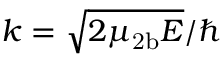<formula> <loc_0><loc_0><loc_500><loc_500>k = \sqrt { 2 \mu _ { 2 b } E } / \hbar</formula> 